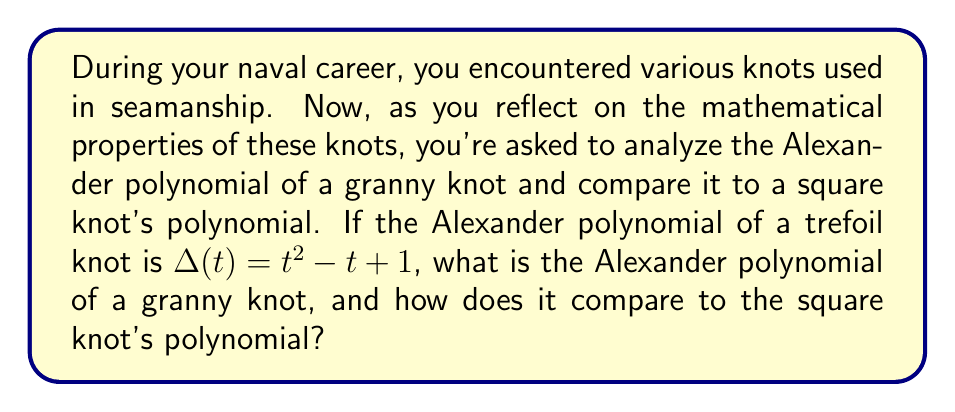What is the answer to this math problem? Let's approach this step-by-step:

1. Recall that a granny knot is formed by joining two trefoil knots with the same chirality, while a square knot joins two trefoil knots of opposite chirality.

2. The Alexander polynomial has a multiplicative property for composite knots:
   If $K = K_1 \# K_2$, then $\Delta_K(t) = \Delta_{K_1}(t) \cdot \Delta_{K_2}(t)$

3. For a granny knot:
   $\Delta_{granny}(t) = \Delta_{trefoil}(t) \cdot \Delta_{trefoil}(t)$
   $\Delta_{granny}(t) = (t^2 - t + 1) \cdot (t^2 - t + 1)$
   $\Delta_{granny}(t) = t^4 - t^3 + t^2 - t^3 + t^2 - t + t^2 - t + 1$
   $\Delta_{granny}(t) = t^4 - 2t^3 + 3t^2 - 2t + 1$

4. For a square knot:
   The calculation is the same, as the Alexander polynomial doesn't distinguish between left and right trefoils.
   $\Delta_{square}(t) = \Delta_{trefoil}(t) \cdot \Delta_{trefoil}(t)$
   $\Delta_{square}(t) = t^4 - 2t^3 + 3t^2 - 2t + 1$

5. Comparison:
   The Alexander polynomials for both the granny knot and the square knot are identical:
   $\Delta_{granny}(t) = \Delta_{square}(t) = t^4 - 2t^3 + 3t^2 - 2t + 1$

This demonstrates a limitation of the Alexander polynomial: it cannot distinguish between these two different knots.
Answer: $\Delta_{granny}(t) = \Delta_{square}(t) = t^4 - 2t^3 + 3t^2 - 2t + 1$ 